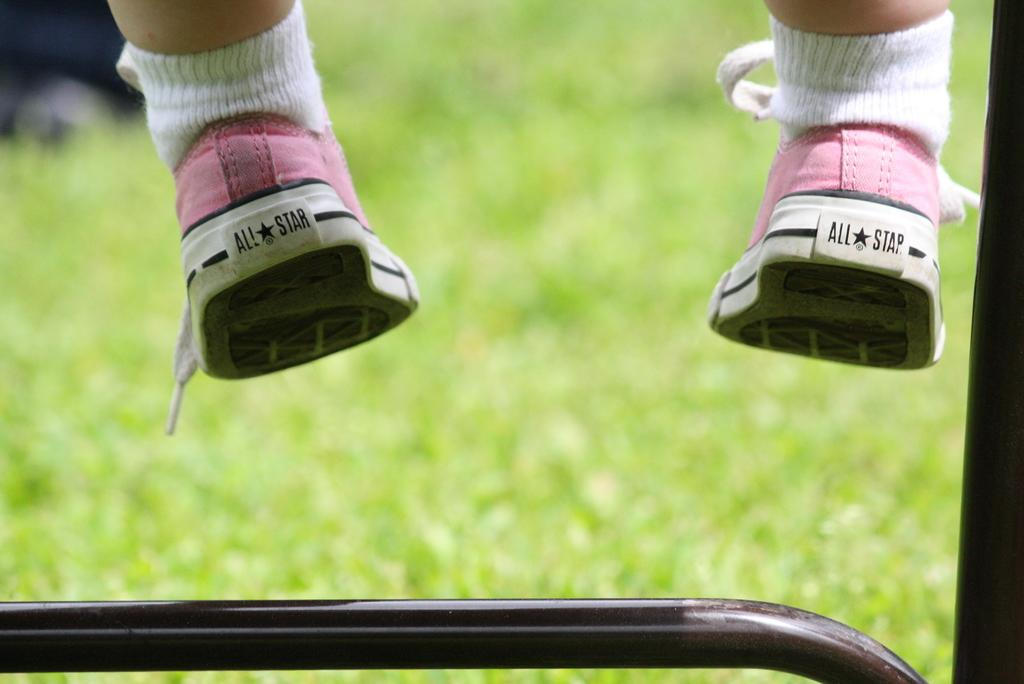Who or what is the main subject in the image? There is a person in the image. What type of footwear is the person wearing? The person is wearing socks and shoes. Can you describe any objects or structures at the bottom of the image? There is a metal rod at the bottom of the image. How would you describe the background of the image? The background of the image is blurred. What type of lumber is being used to tell a story in the image? There is no lumber or storytelling activity present in the image. What arithmetic problem is being solved by the person in the image? There is no arithmetic problem being solved in the image; the person's activity is not specified. 